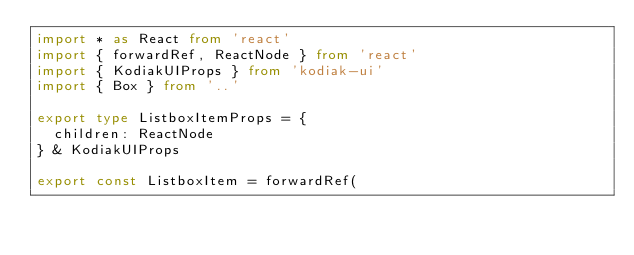<code> <loc_0><loc_0><loc_500><loc_500><_TypeScript_>import * as React from 'react'
import { forwardRef, ReactNode } from 'react'
import { KodiakUIProps } from 'kodiak-ui'
import { Box } from '..'

export type ListboxItemProps = {
  children: ReactNode
} & KodiakUIProps

export const ListboxItem = forwardRef(</code> 